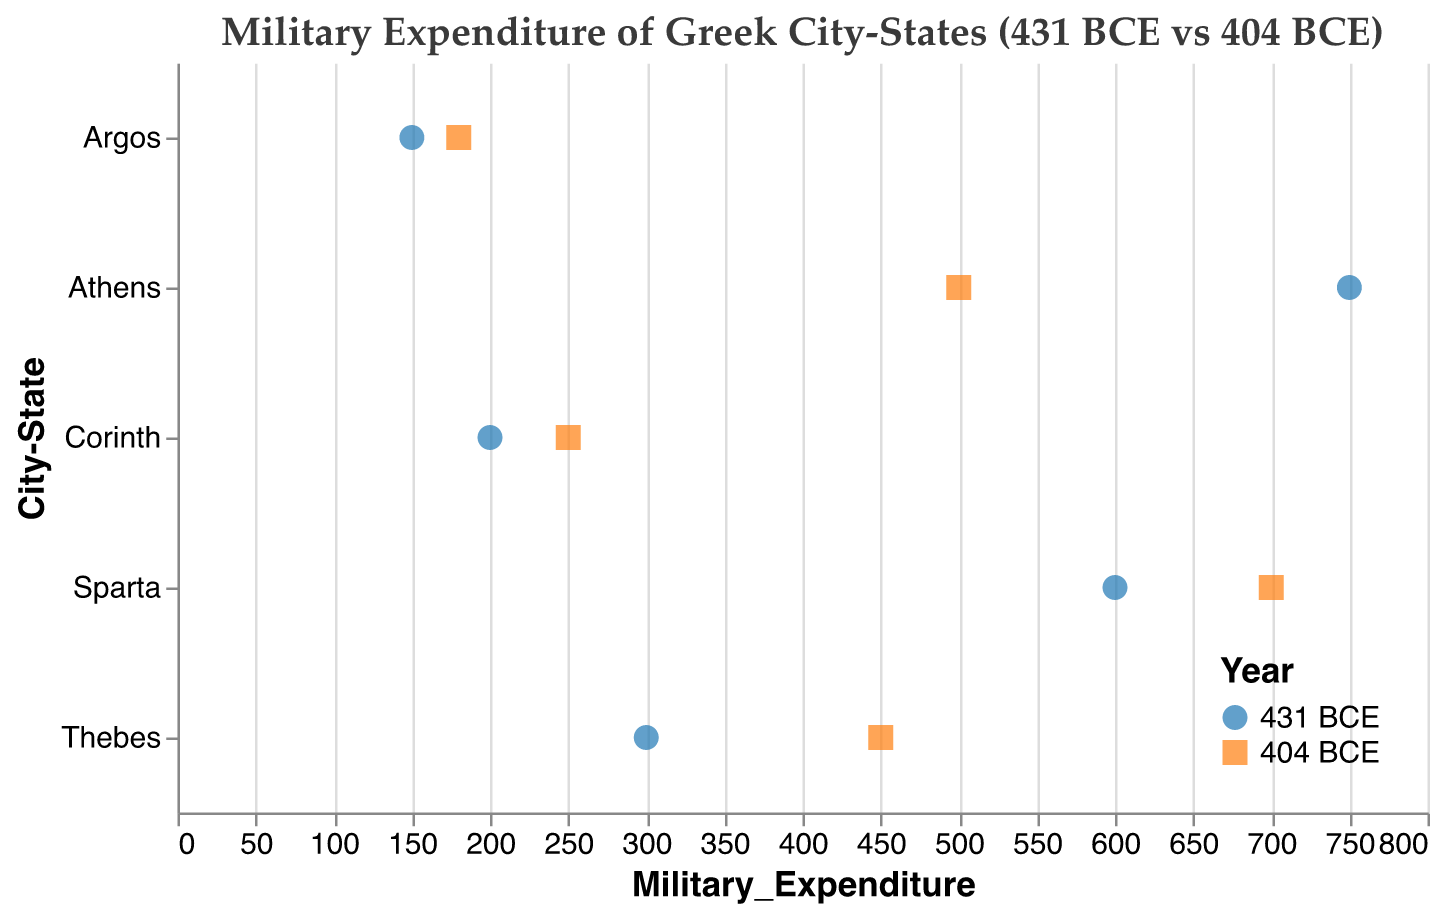What is the military expenditure of Athens in 431 BCE? Look at the data point for Athens labeled with the year 431 BCE. The figure shows the military expenditure at that point to be 750.
Answer: 750 What is the difference in military expenditure for Sparta between 431 BCE and 404 BCE? Locate the data points for Sparta in 431 BCE and 404 BCE. The military expenditure in 431 BCE is 600, and in 404 BCE, it is 700. The difference is 700 - 600.
Answer: 100 Which city-state had the lowest military expenditure in 431 BCE? Review the military expenditures for all city-states in 431 BCE. The lowest value is 150 for Argos.
Answer: Argos Did any city-state increase its military expenditure from 431 BCE to 404 BCE? Compare the military expenditure for each city-state between the two years. Sparta, Thebes, Corinth, and Argos show an increase, while Athens shows a decrease.
Answer: Yes, Sparta, Thebes, Corinth, Argos What is the total military expenditure of all city-states in 404 BCE? Sum the military expenditures of all city-states in 404 BCE: 500 (Athens) + 700 (Sparta) + 450 (Thebes) + 250 (Corinth) + 180 (Argos). The total is 2080.
Answer: 2080 How does the military expenditure change for Corinth from 431 BCE to 404 BCE? Compare the military expenditure of Corinth in the two years. In 431 BCE, it is 200, and in 404 BCE, it is 250. The change is an increase of 50.
Answer: Increase by 50 Which city-state had the highest military expenditure in 431 BCE? Review the military expenditures for all city-states in 431 BCE. The highest value is 750 for Athens.
Answer: Athens What is the average military expenditure of Thebes in 431 BCE and 404 BCE? Take the military expenditures of Thebes in 431 BCE and 404 BCE: 300 and 450. Sum them up to get 750, then divide by 2 for the average. The average is 750 / 2.
Answer: 375 How did the military expenditure of Athens change from 431 BCE to 404 BCE? Compare the military expenditure of Athens in the two years. In 431 BCE, it is 750, and in 404 BCE, it is 500. The change is a decrease of 250.
Answer: Decrease by 250 What is the range of military expenditures across all city-states in 404 BCE? Identify the lowest and highest military expenditures in 404 BCE. The lowest is 180 (Argos) and the highest is 700 (Sparta). The range is 700 - 180.
Answer: 520 